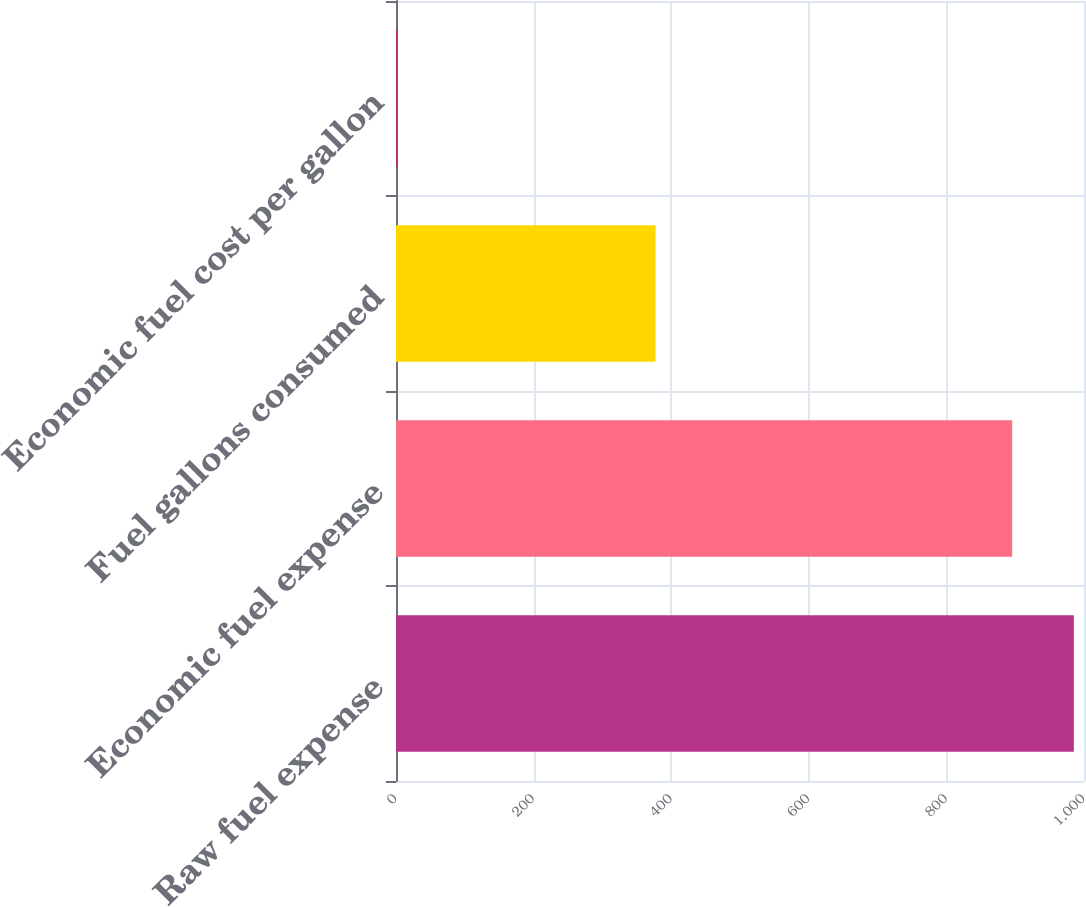<chart> <loc_0><loc_0><loc_500><loc_500><bar_chart><fcel>Raw fuel expense<fcel>Economic fuel expense<fcel>Fuel gallons consumed<fcel>Economic fuel cost per gallon<nl><fcel>985.25<fcel>895.6<fcel>377.3<fcel>2.37<nl></chart> 